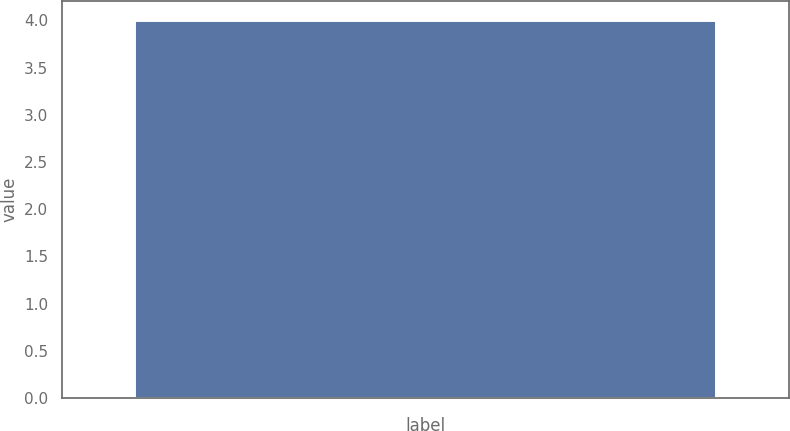Convert chart to OTSL. <chart><loc_0><loc_0><loc_500><loc_500><bar_chart><ecel><nl><fcel>4<nl></chart> 